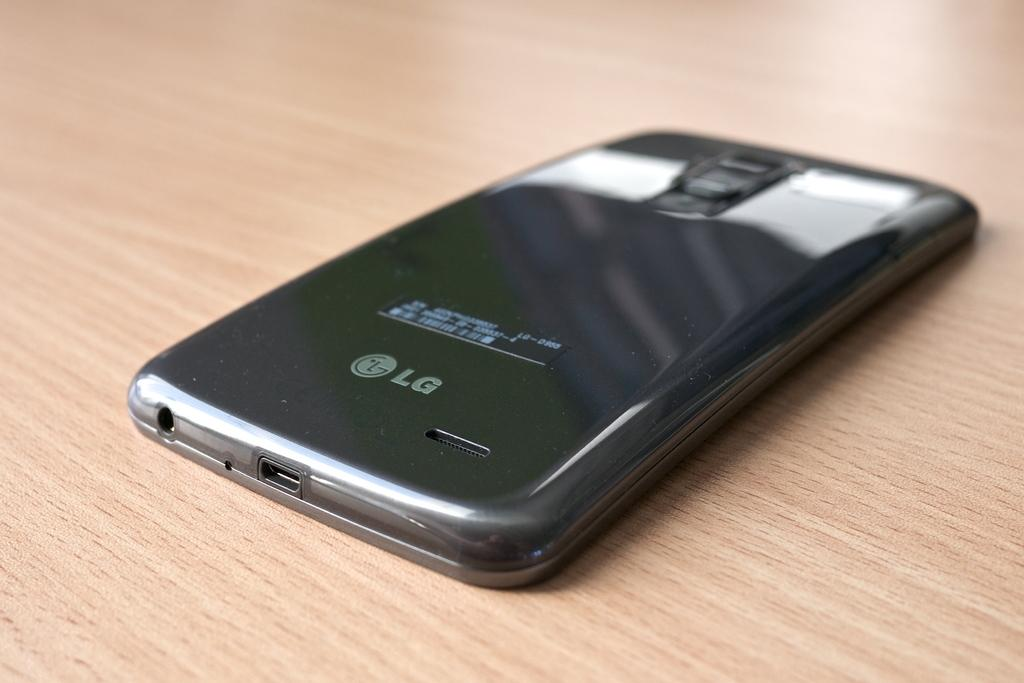Provide a one-sentence caption for the provided image. The black phone sitting face down on the table is a LG phone. 